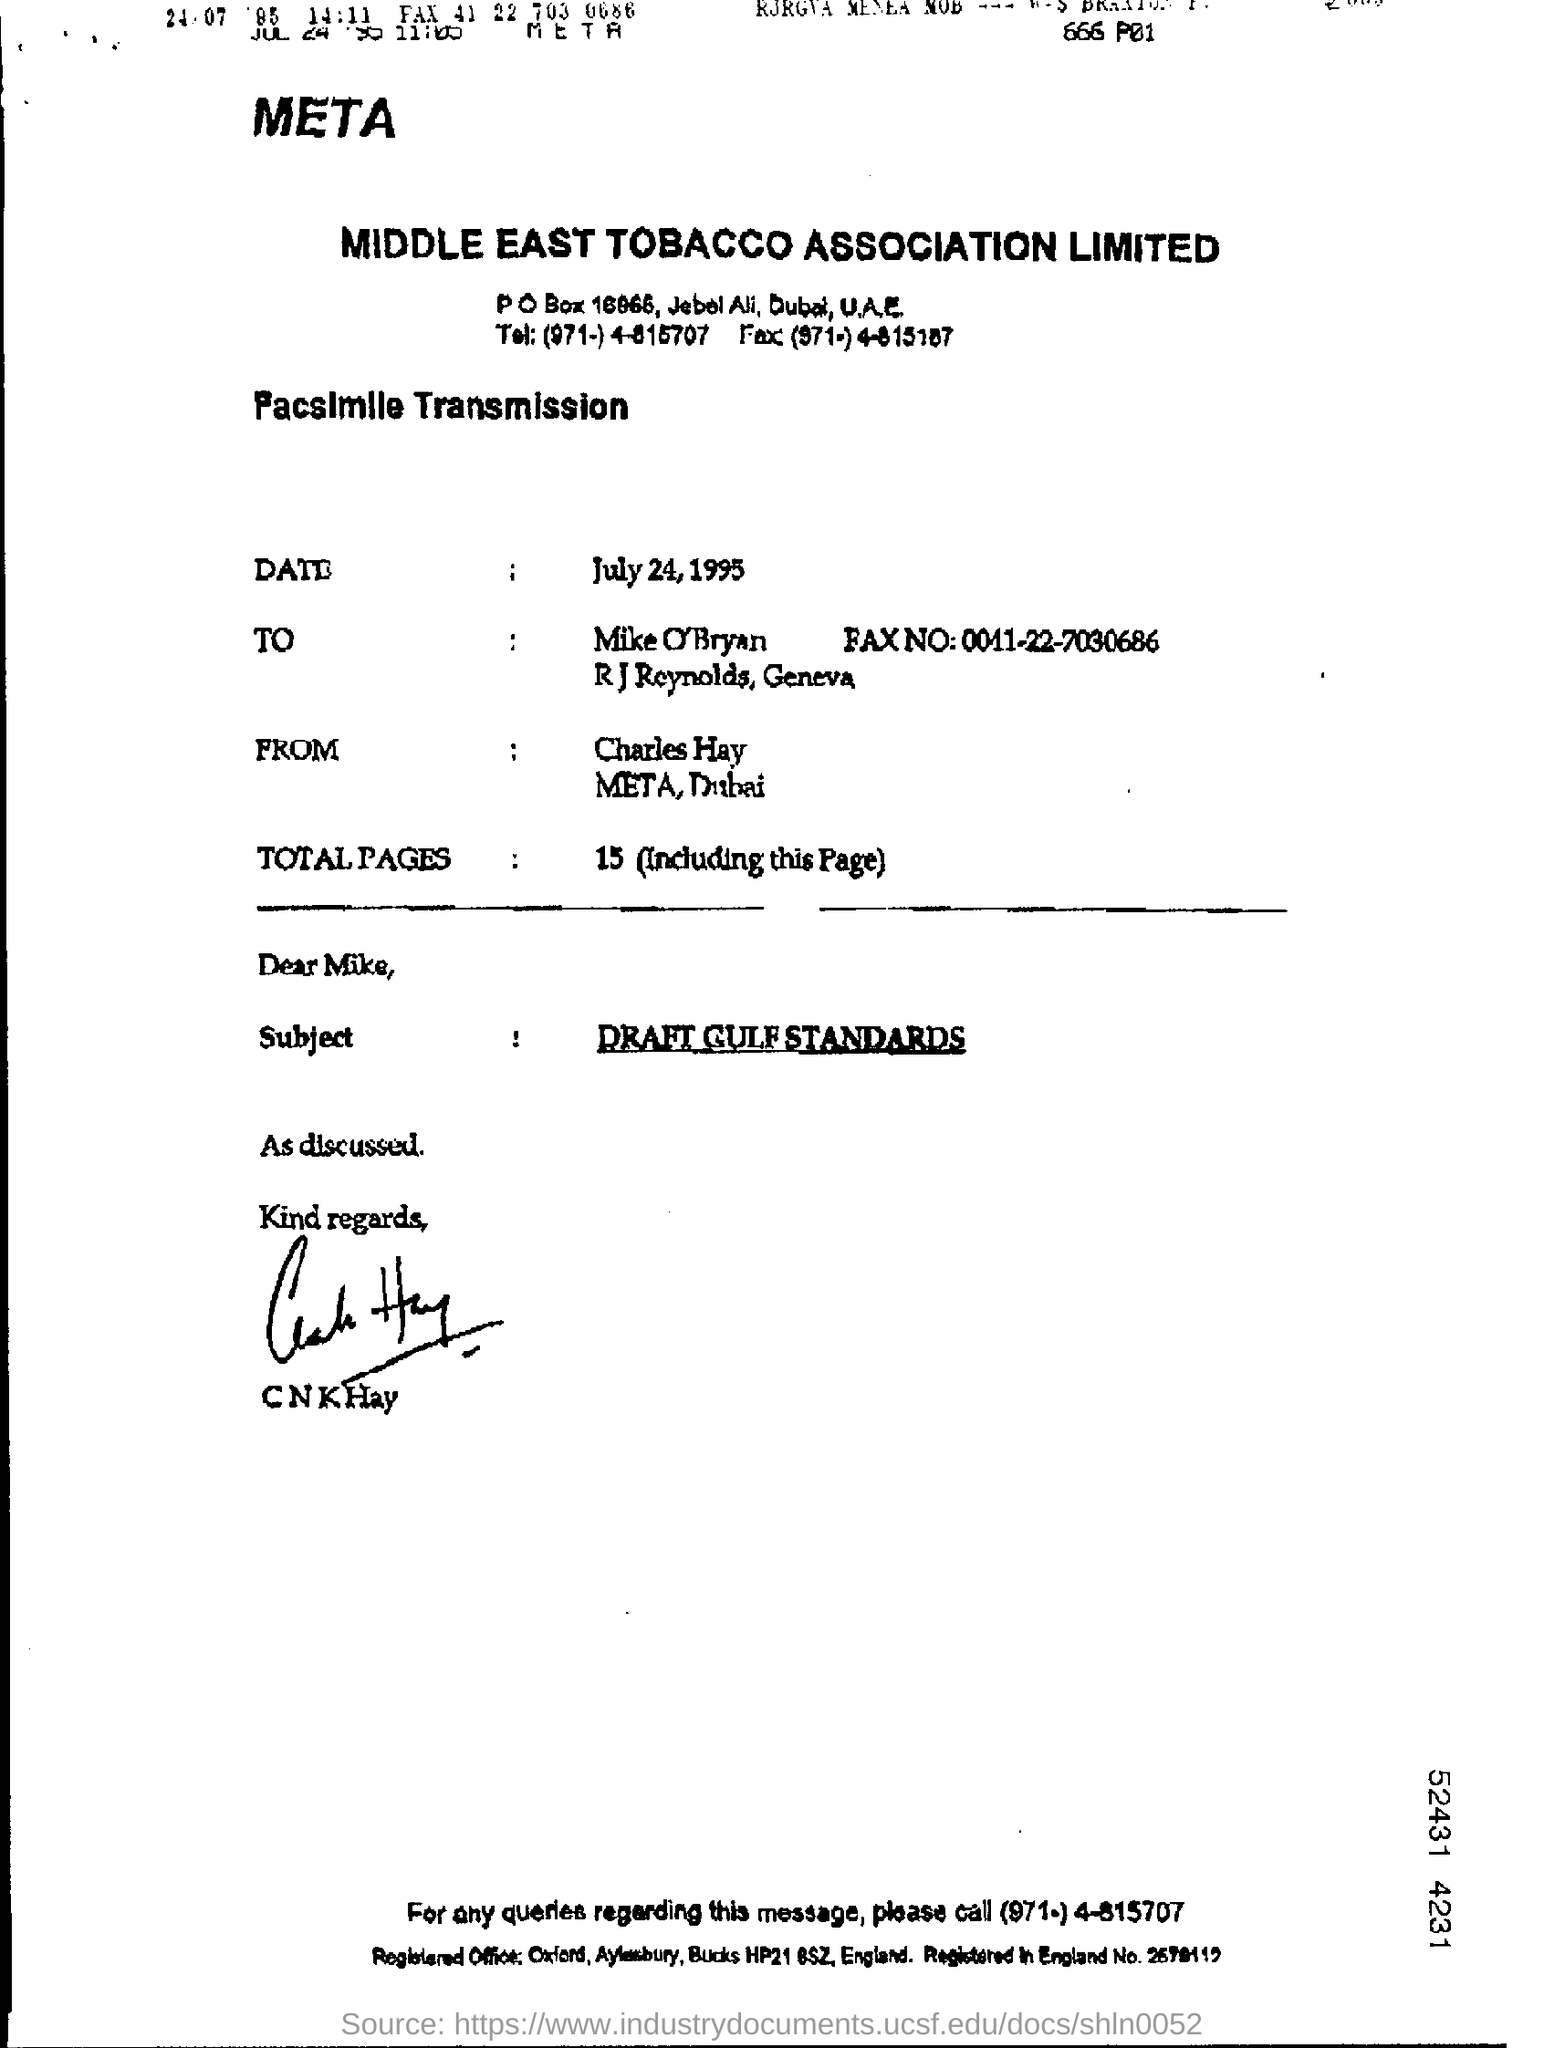What is the subject of the facsimile transmission?
Provide a short and direct response. DRAFT GULF STANDARDS. 